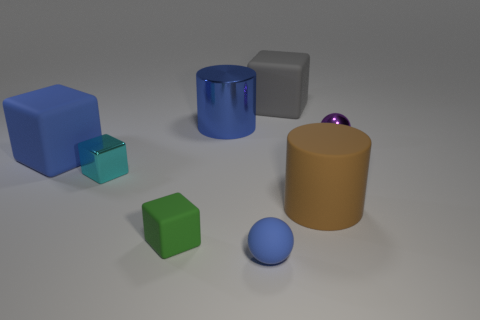Subtract all purple blocks. Subtract all purple cylinders. How many blocks are left? 4 Add 2 brown rubber objects. How many objects exist? 10 Subtract all spheres. How many objects are left? 6 Subtract all gray blocks. Subtract all matte cylinders. How many objects are left? 6 Add 7 big blue rubber blocks. How many big blue rubber blocks are left? 8 Add 3 tiny green matte things. How many tiny green matte things exist? 4 Subtract 0 gray spheres. How many objects are left? 8 